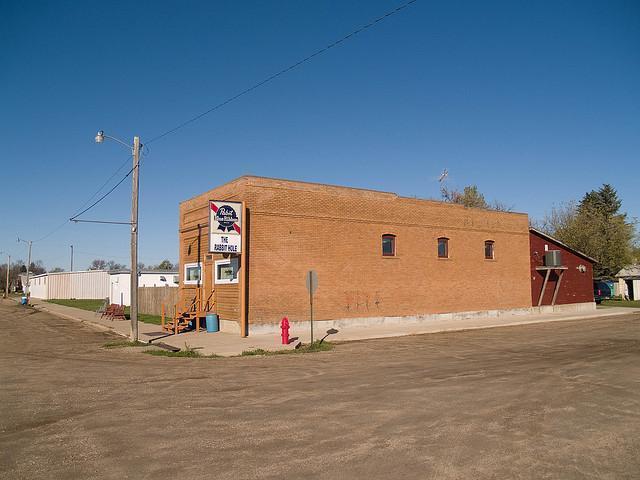How many yard are there humps?
Give a very brief answer. 0. How many cars are in the picture?
Give a very brief answer. 0. 